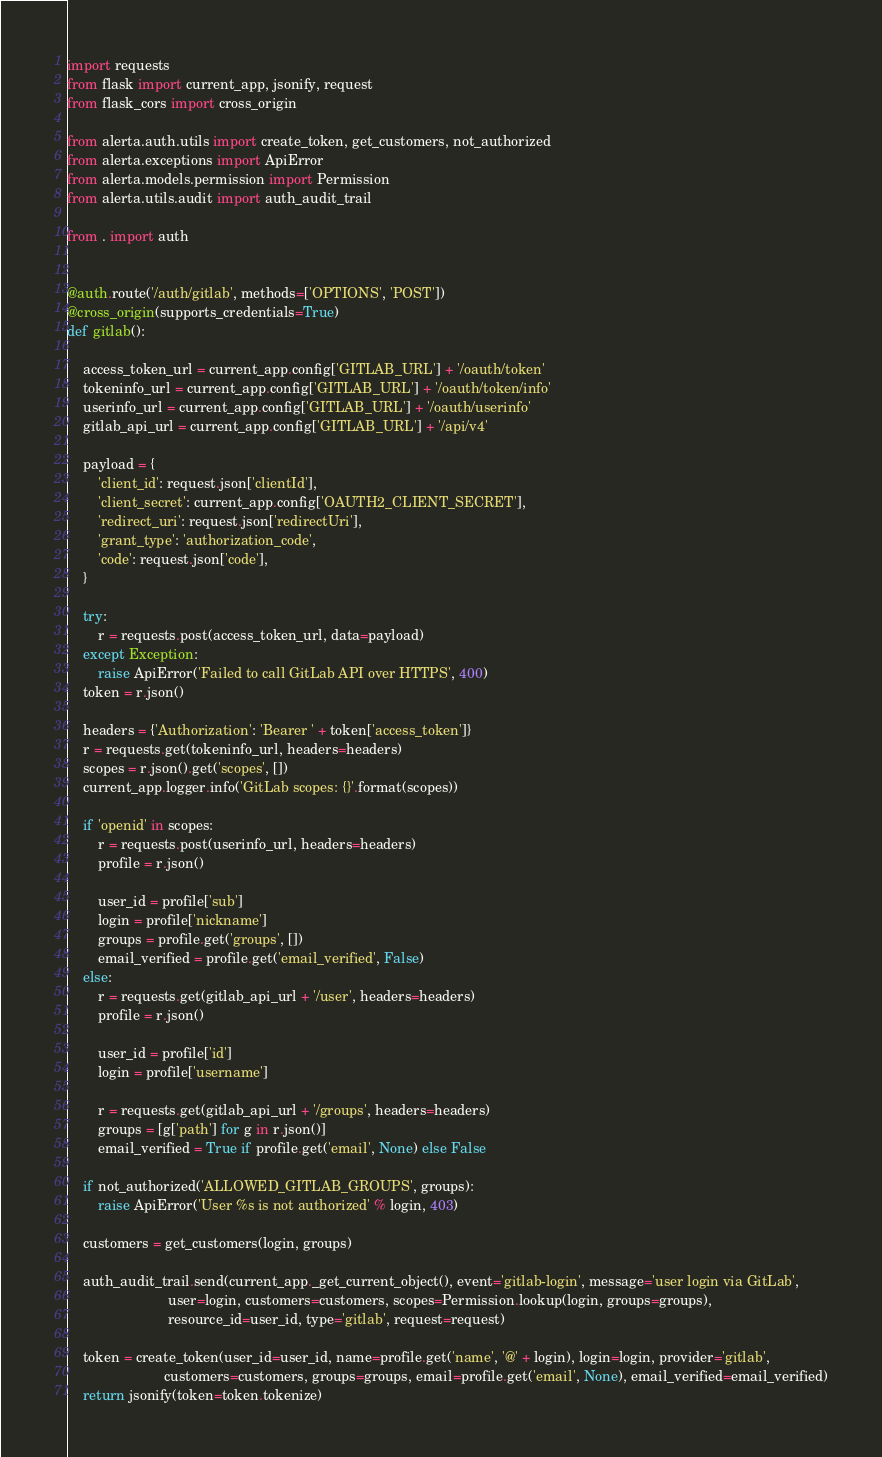<code> <loc_0><loc_0><loc_500><loc_500><_Python_>
import requests
from flask import current_app, jsonify, request
from flask_cors import cross_origin

from alerta.auth.utils import create_token, get_customers, not_authorized
from alerta.exceptions import ApiError
from alerta.models.permission import Permission
from alerta.utils.audit import auth_audit_trail

from . import auth


@auth.route('/auth/gitlab', methods=['OPTIONS', 'POST'])
@cross_origin(supports_credentials=True)
def gitlab():

    access_token_url = current_app.config['GITLAB_URL'] + '/oauth/token'
    tokeninfo_url = current_app.config['GITLAB_URL'] + '/oauth/token/info'
    userinfo_url = current_app.config['GITLAB_URL'] + '/oauth/userinfo'
    gitlab_api_url = current_app.config['GITLAB_URL'] + '/api/v4'

    payload = {
        'client_id': request.json['clientId'],
        'client_secret': current_app.config['OAUTH2_CLIENT_SECRET'],
        'redirect_uri': request.json['redirectUri'],
        'grant_type': 'authorization_code',
        'code': request.json['code'],
    }

    try:
        r = requests.post(access_token_url, data=payload)
    except Exception:
        raise ApiError('Failed to call GitLab API over HTTPS', 400)
    token = r.json()

    headers = {'Authorization': 'Bearer ' + token['access_token']}
    r = requests.get(tokeninfo_url, headers=headers)
    scopes = r.json().get('scopes', [])
    current_app.logger.info('GitLab scopes: {}'.format(scopes))

    if 'openid' in scopes:
        r = requests.post(userinfo_url, headers=headers)
        profile = r.json()

        user_id = profile['sub']
        login = profile['nickname']
        groups = profile.get('groups', [])
        email_verified = profile.get('email_verified', False)
    else:
        r = requests.get(gitlab_api_url + '/user', headers=headers)
        profile = r.json()

        user_id = profile['id']
        login = profile['username']

        r = requests.get(gitlab_api_url + '/groups', headers=headers)
        groups = [g['path'] for g in r.json()]
        email_verified = True if profile.get('email', None) else False

    if not_authorized('ALLOWED_GITLAB_GROUPS', groups):
        raise ApiError('User %s is not authorized' % login, 403)

    customers = get_customers(login, groups)

    auth_audit_trail.send(current_app._get_current_object(), event='gitlab-login', message='user login via GitLab',
                          user=login, customers=customers, scopes=Permission.lookup(login, groups=groups),
                          resource_id=user_id, type='gitlab', request=request)

    token = create_token(user_id=user_id, name=profile.get('name', '@' + login), login=login, provider='gitlab',
                         customers=customers, groups=groups, email=profile.get('email', None), email_verified=email_verified)
    return jsonify(token=token.tokenize)
</code> 